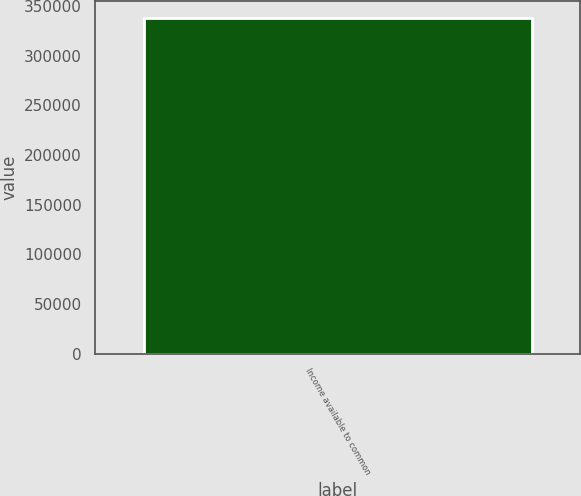Convert chart to OTSL. <chart><loc_0><loc_0><loc_500><loc_500><bar_chart><fcel>Income available to common<nl><fcel>337999<nl></chart> 